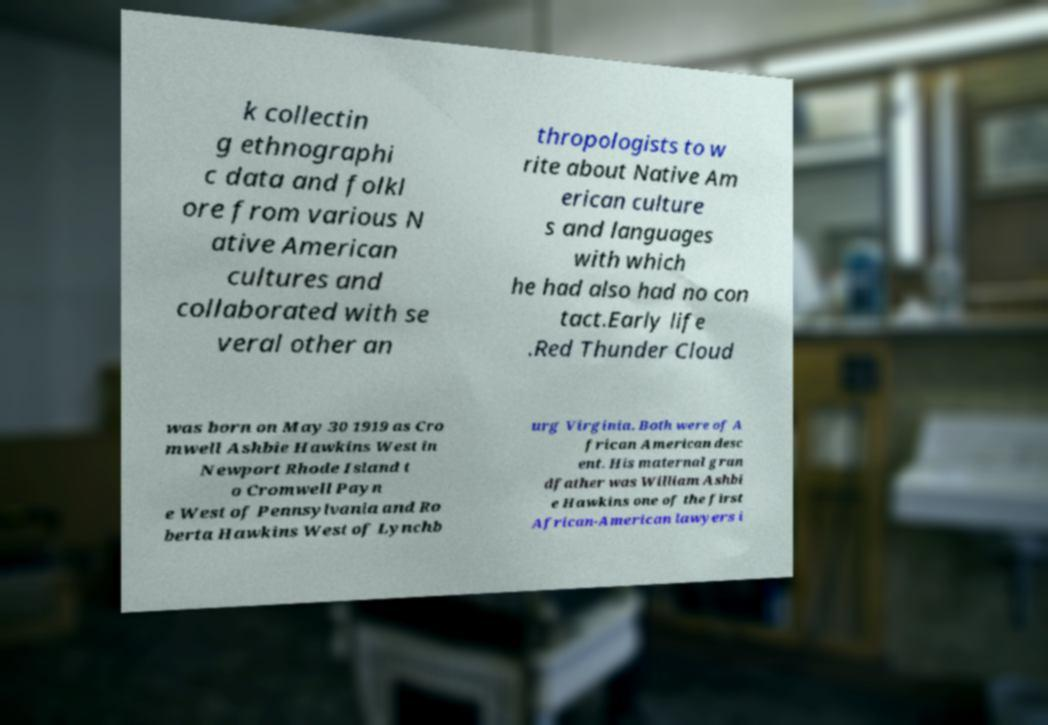There's text embedded in this image that I need extracted. Can you transcribe it verbatim? k collectin g ethnographi c data and folkl ore from various N ative American cultures and collaborated with se veral other an thropologists to w rite about Native Am erican culture s and languages with which he had also had no con tact.Early life .Red Thunder Cloud was born on May 30 1919 as Cro mwell Ashbie Hawkins West in Newport Rhode Island t o Cromwell Payn e West of Pennsylvania and Ro berta Hawkins West of Lynchb urg Virginia. Both were of A frican American desc ent. His maternal gran dfather was William Ashbi e Hawkins one of the first African-American lawyers i 